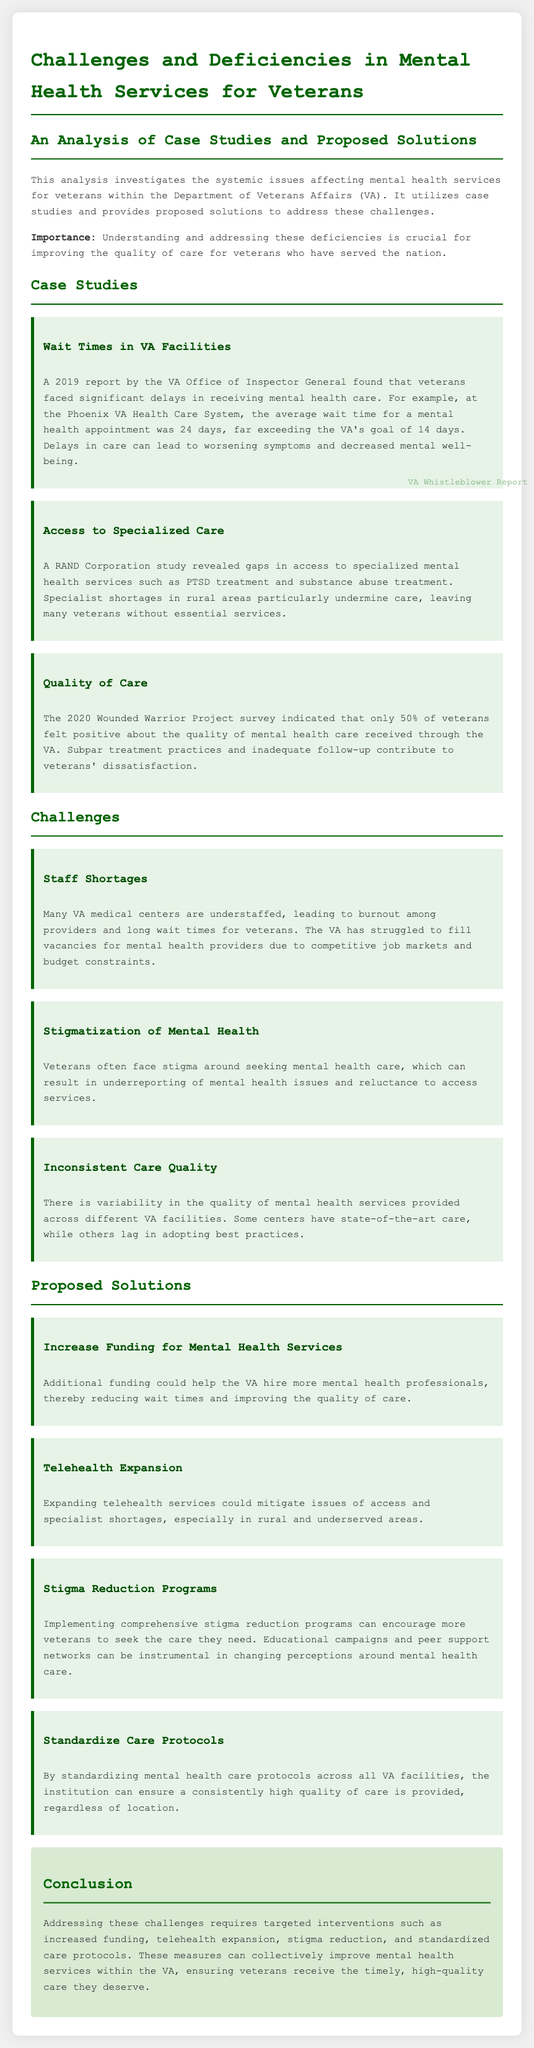What was the average wait time for a mental health appointment at the Phoenix VA Health Care System? The document specifically mentions that the average wait time for a mental health appointment was 24 days.
Answer: 24 days What percentage of veterans felt positive about the quality of care received through the VA according to the 2020 Wounded Warrior Project survey? The survey indicated that only 50% of veterans felt positive about the quality of mental health care received through the VA.
Answer: 50% What factor contributes to veterans' dissatisfaction with mental health care? Subpar treatment practices and inadequate follow-up contribute to veterans' dissatisfaction.
Answer: Subpar treatment practices and inadequate follow-up What challenge does stigmatization of mental health present for veterans? The document states that this stigma can result in underreporting of mental health issues and reluctance to access services.
Answer: Underreporting and reluctance What solution involves the expansion of services in rural areas? Expanding telehealth services is proposed as a solution to mitigate issues of access and specialist shortages.
Answer: Telehealth expansion How can the quality of care be standardized across VA facilities? The document suggests standardizing mental health care protocols across all VA facilities to ensure consistent quality.
Answer: Standardizing care protocols What is a proposed solution for increasing the number of mental health professionals? Additional funding for mental health services is proposed to help the VA hire more professionals and reduce wait times.
Answer: Increase funding Which organization's study revealed gaps in access to specialized mental health services? A RAND Corporation study revealed gaps in access to specialized mental health services.
Answer: RAND Corporation How many case studies are analyzed in this document? The document presents three case studies related to challenges in mental health services for veterans.
Answer: Three 